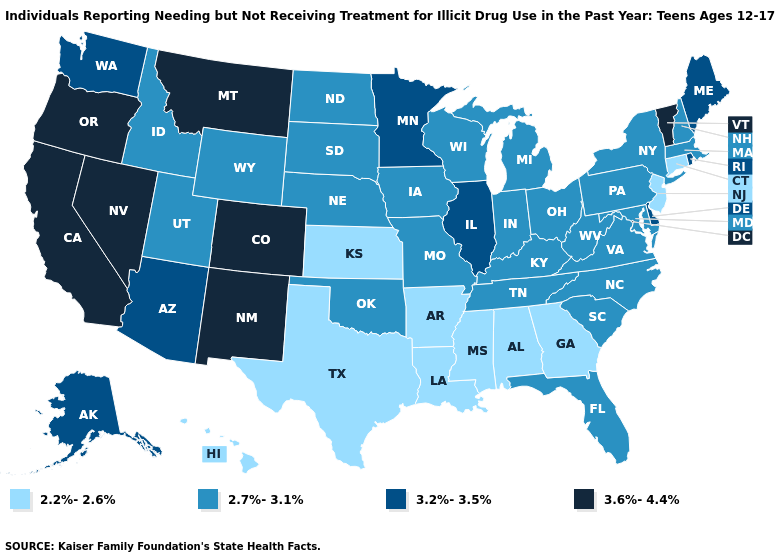Does Montana have the highest value in the USA?
Write a very short answer. Yes. Does North Dakota have a lower value than Delaware?
Write a very short answer. Yes. Name the states that have a value in the range 2.7%-3.1%?
Quick response, please. Florida, Idaho, Indiana, Iowa, Kentucky, Maryland, Massachusetts, Michigan, Missouri, Nebraska, New Hampshire, New York, North Carolina, North Dakota, Ohio, Oklahoma, Pennsylvania, South Carolina, South Dakota, Tennessee, Utah, Virginia, West Virginia, Wisconsin, Wyoming. What is the value of Nebraska?
Answer briefly. 2.7%-3.1%. What is the value of New Mexico?
Answer briefly. 3.6%-4.4%. What is the value of Missouri?
Be succinct. 2.7%-3.1%. Which states have the highest value in the USA?
Write a very short answer. California, Colorado, Montana, Nevada, New Mexico, Oregon, Vermont. Which states have the lowest value in the South?
Concise answer only. Alabama, Arkansas, Georgia, Louisiana, Mississippi, Texas. What is the value of Georgia?
Answer briefly. 2.2%-2.6%. Does Texas have a higher value than New Jersey?
Quick response, please. No. Among the states that border North Dakota , does Minnesota have the highest value?
Write a very short answer. No. Name the states that have a value in the range 3.6%-4.4%?
Answer briefly. California, Colorado, Montana, Nevada, New Mexico, Oregon, Vermont. What is the highest value in the Northeast ?
Write a very short answer. 3.6%-4.4%. Name the states that have a value in the range 2.7%-3.1%?
Quick response, please. Florida, Idaho, Indiana, Iowa, Kentucky, Maryland, Massachusetts, Michigan, Missouri, Nebraska, New Hampshire, New York, North Carolina, North Dakota, Ohio, Oklahoma, Pennsylvania, South Carolina, South Dakota, Tennessee, Utah, Virginia, West Virginia, Wisconsin, Wyoming. Which states hav the highest value in the South?
Quick response, please. Delaware. 